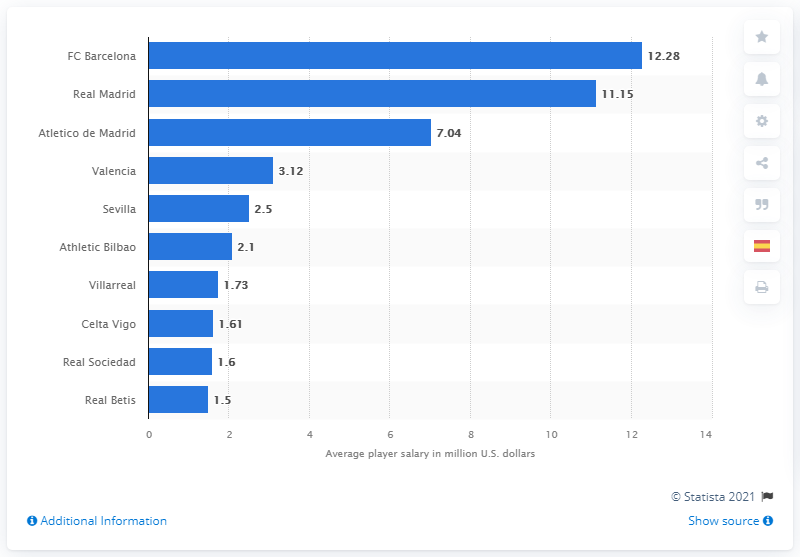Point out several critical features in this image. In the 2019/20 season, Real Madrid had the highest pay per player, making it the team with the highest financial resources. In the 2019/20 season, Atletico de Madrid had the highest pay per player among all teams. The average annual pay for players in the 2019/20 season was 12.28. 